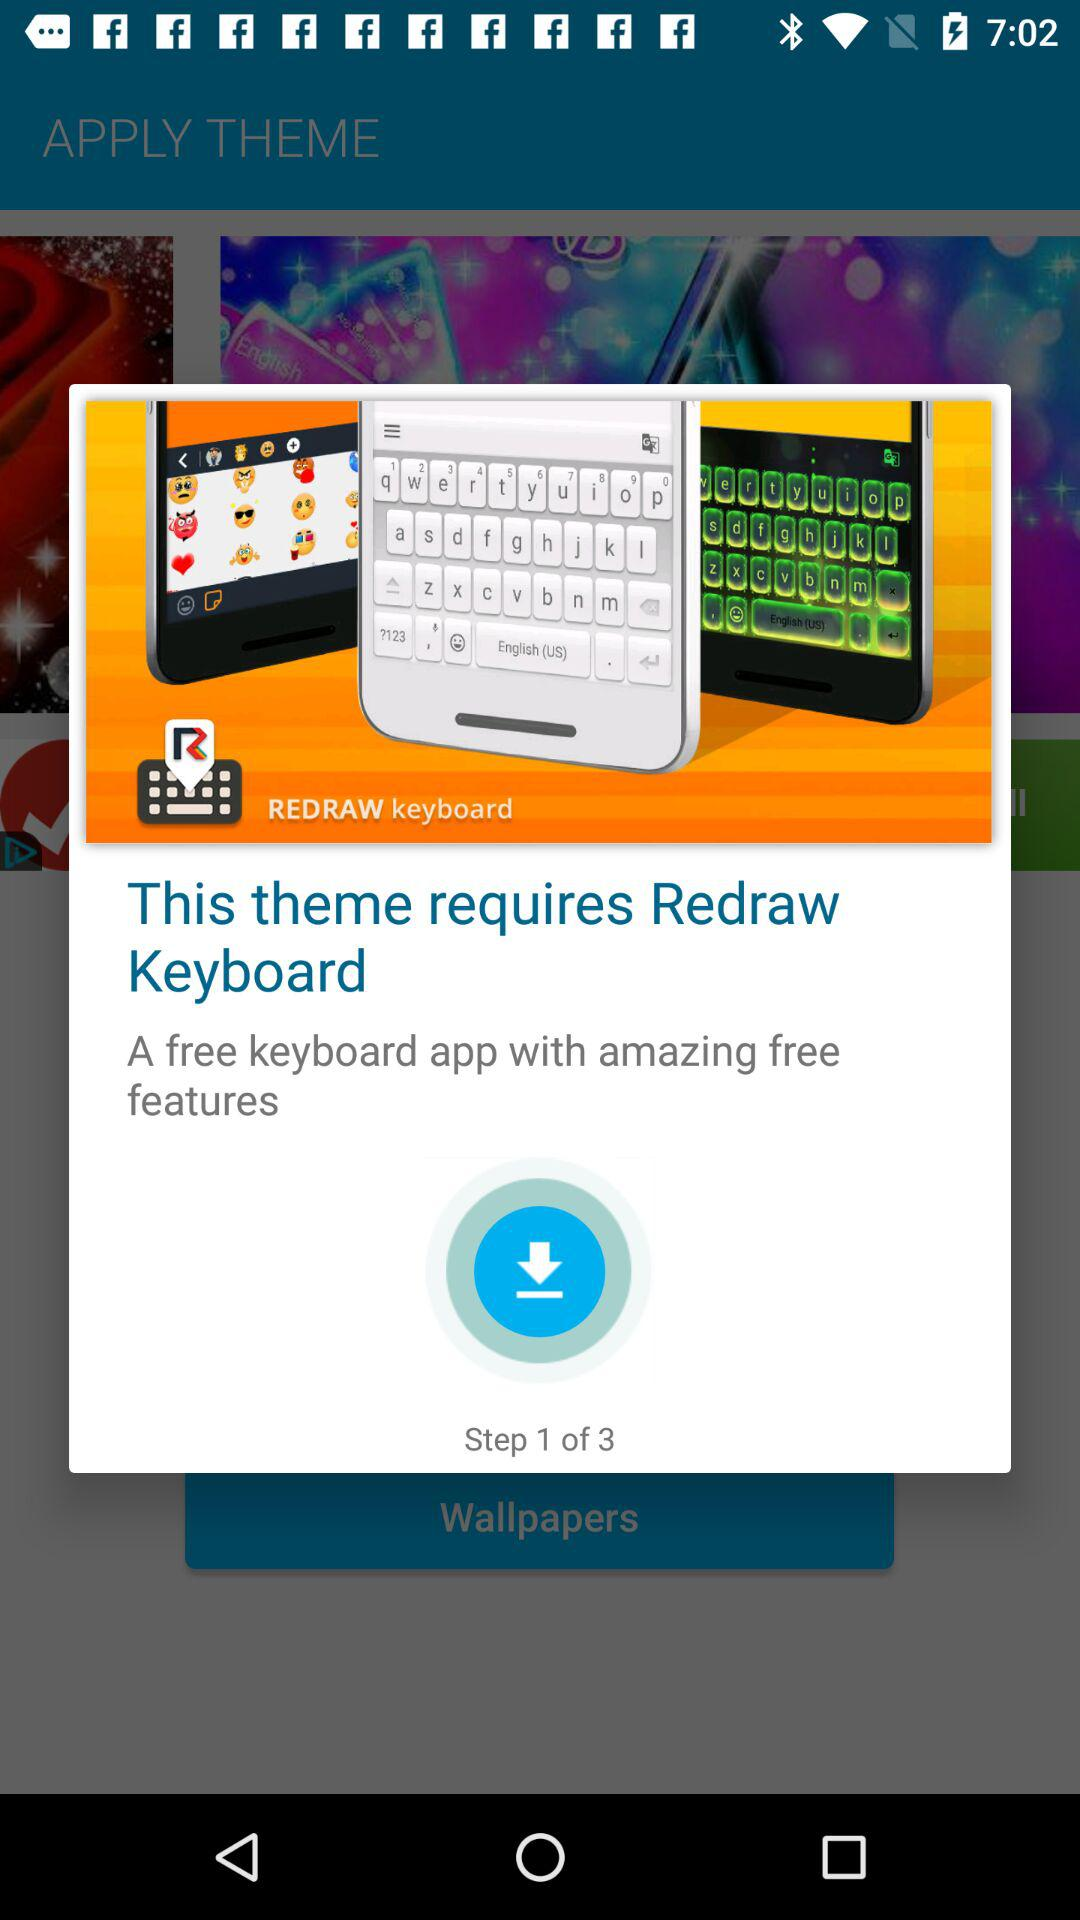At which step are we? You are at the first step. 